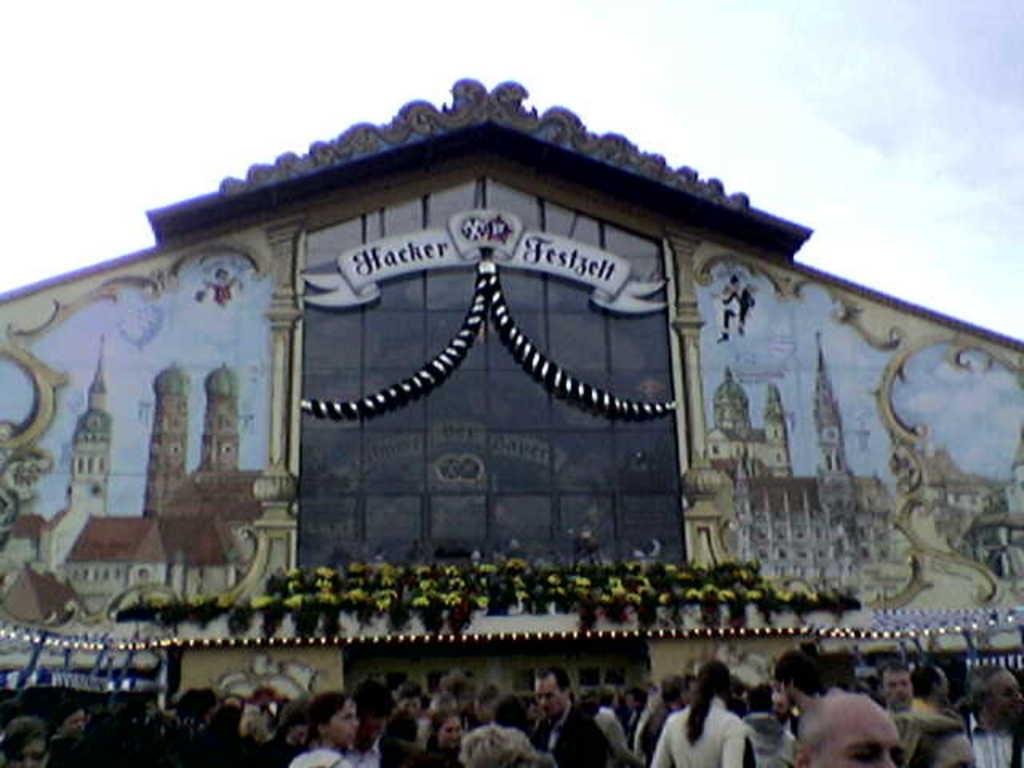What is the word on the left half of the sign?
Make the answer very short. Hacker. What is the first letter of the word on the right side of the sign?
Provide a succinct answer. F. 